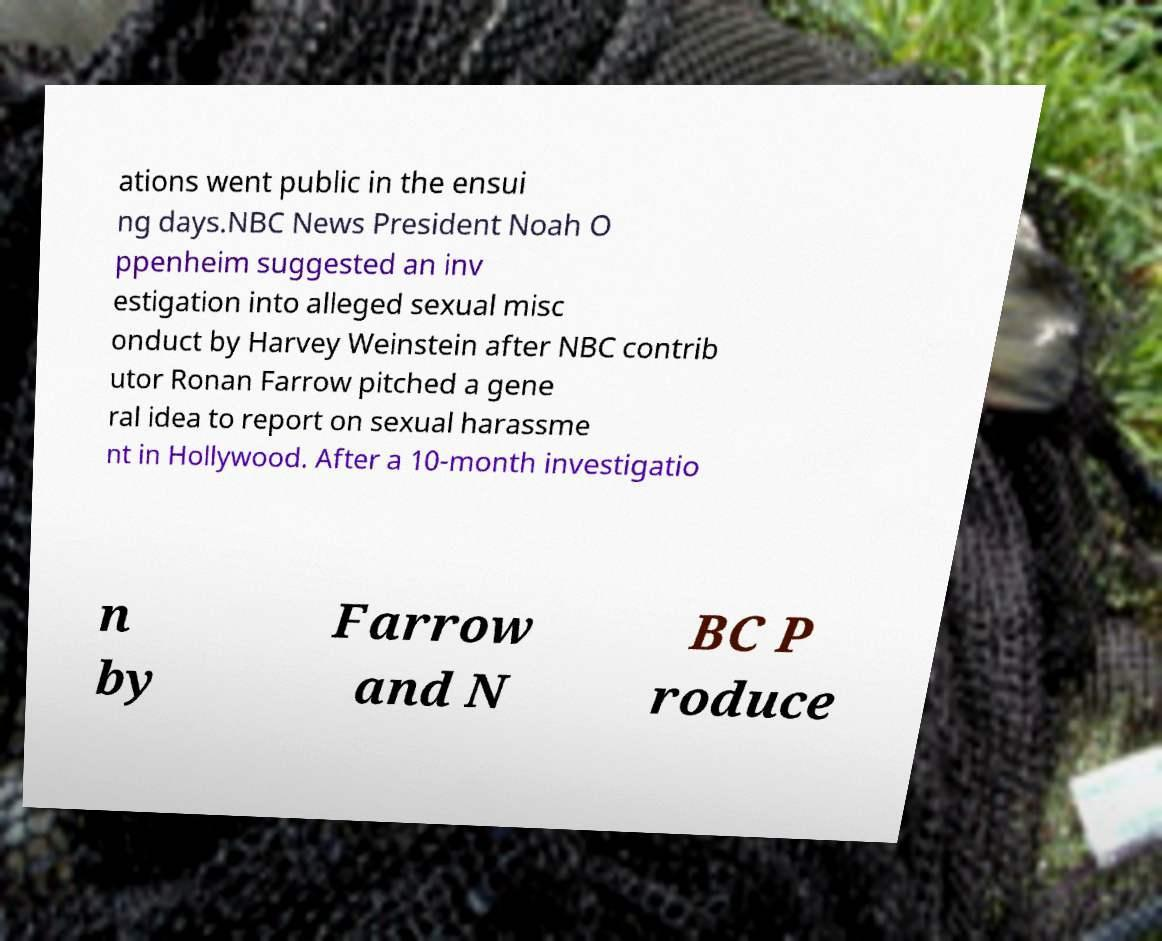Can you accurately transcribe the text from the provided image for me? ations went public in the ensui ng days.NBC News President Noah O ppenheim suggested an inv estigation into alleged sexual misc onduct by Harvey Weinstein after NBC contrib utor Ronan Farrow pitched a gene ral idea to report on sexual harassme nt in Hollywood. After a 10-month investigatio n by Farrow and N BC P roduce 